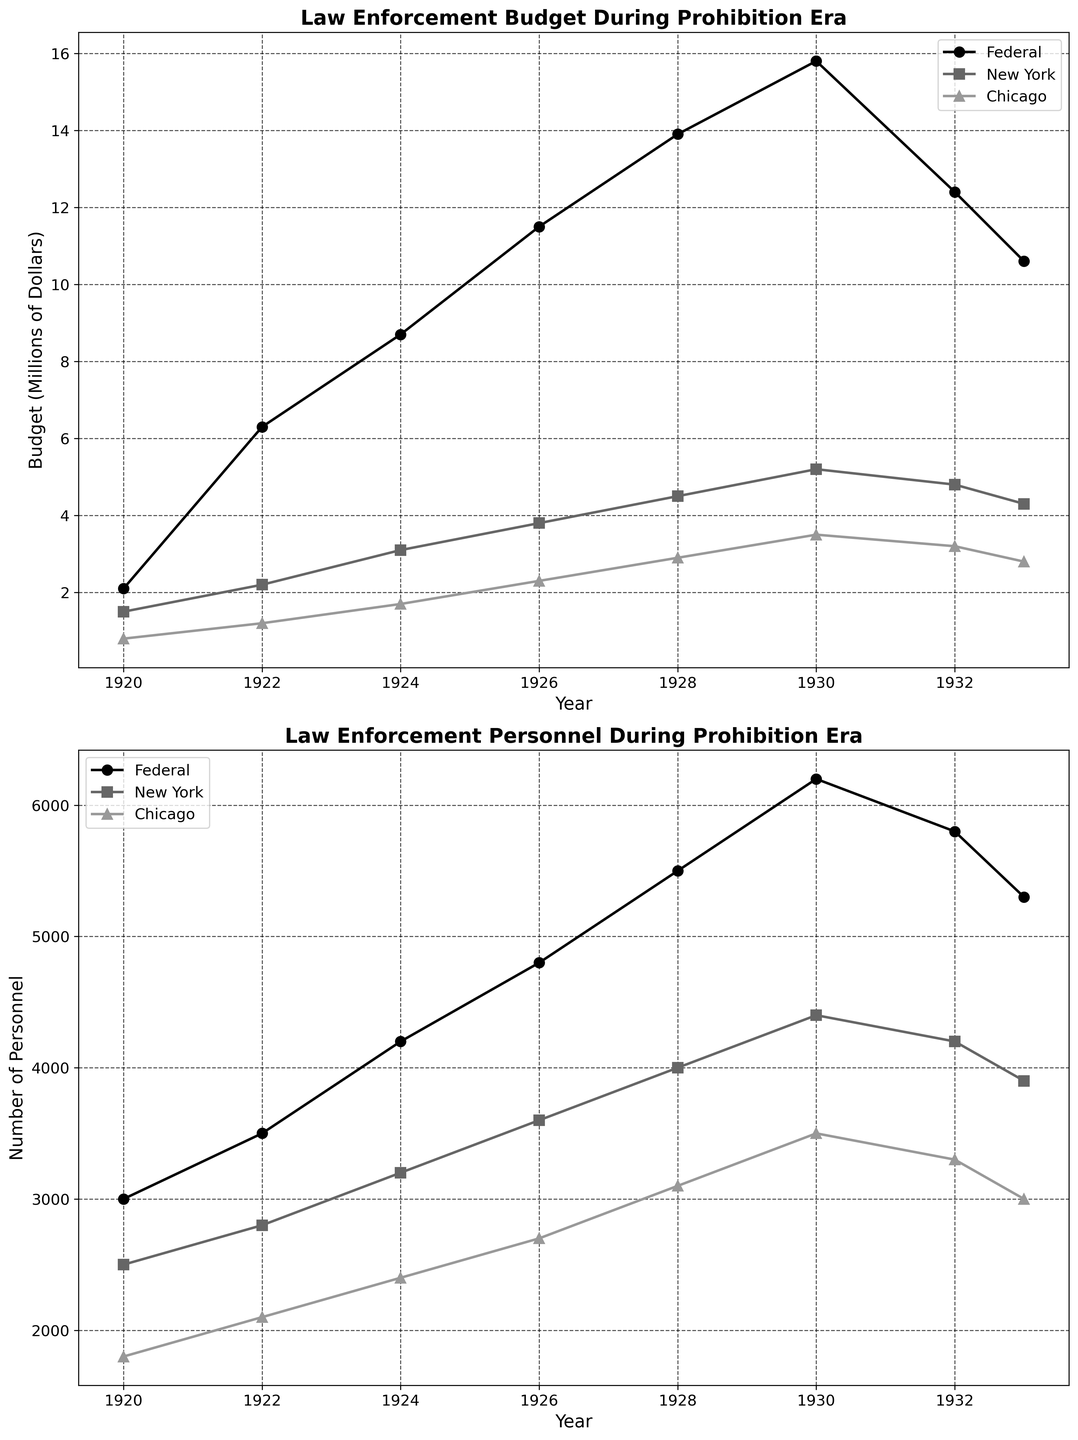What is the title of the first subplot? The title of the first subplot is written at the top of that subplot. It is 'Law Enforcement Budget During Prohibition Era'.
Answer: Law Enforcement Budget During Prohibition Era What is the maximum budget allocation for Federal law enforcement, and in which year did it occur? To find the maximum budget allocation for Federal law enforcement, look at the highest point on the Federal budget line in the first subplot. The highest point occurs in 1930 with a budget of $15.8 million.
Answer: $15.8 million in 1930 How did the number of personnel in Chicago law enforcement change from 1922 to 1933? Look at the second subplot for Chicago's personnel line. In 1922, there were 2100 personnel, and by 1933, there were 3000 personnel. The change is an increase of 3000 - 2100 = 900 personnel.
Answer: Increased by 900 personnel Between New York and Chicago, which city had a higher budget in 1926 and by how much? Check the first subplot for New York and Chicago budgets in 1926. New York's budget was $3.8 million, and Chicago's was $2.3 million. The difference is $3.8 million - $2.3 million = $1.5 million. Thus, New York had a higher budget by $1.5 million.
Answer: New York by $1.5 million What trend do you observe in the Federal personnel numbers from 1928 to 1933? In the second subplot, observe the Federal personnel numbers from 1928 (5500 personnel) to 1933 (5300 personnel). The numbers initially increased from 5500 to 6200 by 1930 and then decreased to 5300 by 1933.
Answer: Increased and then decreased Which year saw the largest difference in budget allocation between New York and Chicago, and what was the difference? Look at the first subplot and calculate the budget difference between New York and Chicago for each year. The largest difference is in 1930: New York had $5.2 million and Chicago had $3.5 million. The difference is $5.2 million - $3.5 million = $1.7 million.
Answer: 1930, $1.7 million Compare the trends in Federal and New York law enforcement budgets from 1924 to 1930. In the first subplot, observe both the Federal and New York budget lines from 1924 to 1930. Both show an upward trend: the Federal budget increased from $8.7 million to $15.8 million, and New York's budget increased from $3.1 million to $5.2 million.
Answer: Both increased In which year did the number of Federal personnel peak, and what was that number? Check the second subplot for the peak in Federal personnel. The peak number of Federal personnel is in 1930 with 6200 personnel.
Answer: 1930, 6200 By how much did the budget for Federal law enforcement decrease from 1930 to 1933? In the first subplot, the Federal budget in 1930 was $15.8 million, and in 1933 it was $10.6 million. The decrease is $15.8 million - $10.6 million = $5.2 million.
Answer: $5.2 million What was the personnel count for New York law enforcement in 1920, and how does it compare to the count in Chicago the same year? In the second subplot, New York had 2500 personnel, and Chicago had 1800 in 1920. New York had 2500 - 1800 = 700 more personnel than Chicago in 1920.
Answer: New York had 700 more personnel 